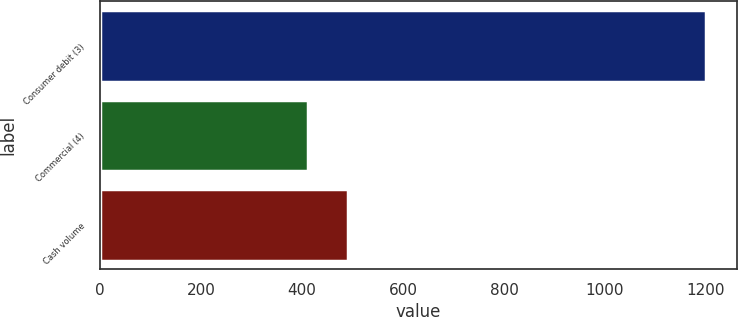Convert chart to OTSL. <chart><loc_0><loc_0><loc_500><loc_500><bar_chart><fcel>Consumer debit (3)<fcel>Commercial (4)<fcel>Cash volume<nl><fcel>1201<fcel>412<fcel>491<nl></chart> 